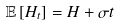Convert formula to latex. <formula><loc_0><loc_0><loc_500><loc_500>\mathbb { E } \left [ H _ { t } \right ] = H + \sigma t</formula> 